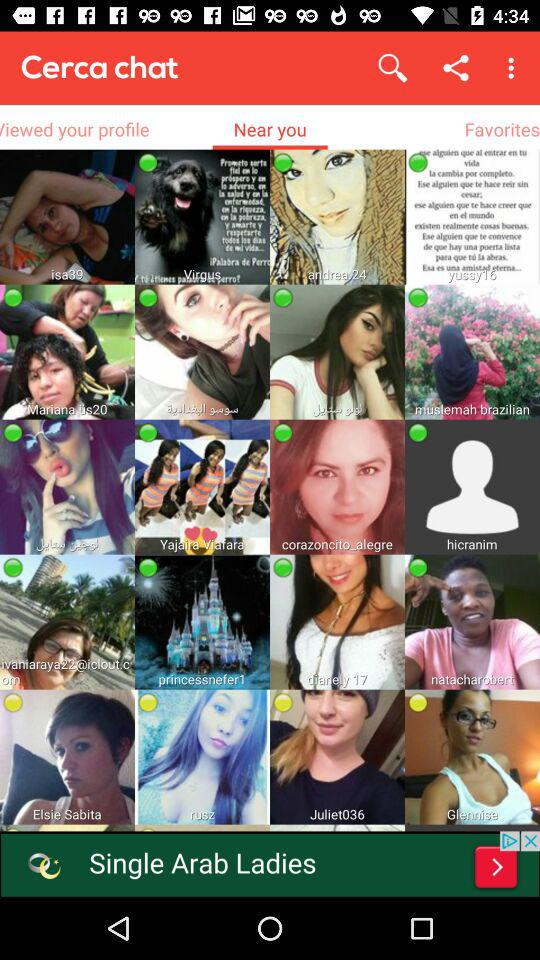What is the age of Andrée?
When the provided information is insufficient, respond with <no answer>. <no answer> 